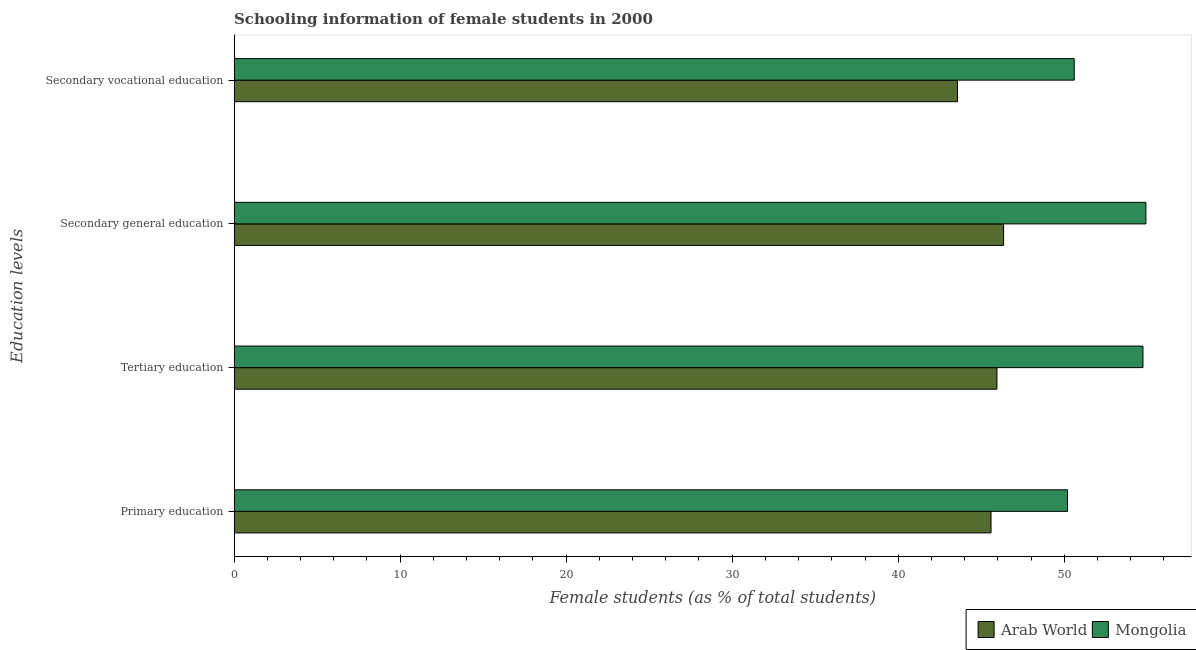How many groups of bars are there?
Keep it short and to the point. 4. Are the number of bars per tick equal to the number of legend labels?
Provide a short and direct response. Yes. Are the number of bars on each tick of the Y-axis equal?
Provide a short and direct response. Yes. How many bars are there on the 1st tick from the bottom?
Ensure brevity in your answer.  2. What is the label of the 2nd group of bars from the top?
Make the answer very short. Secondary general education. What is the percentage of female students in secondary education in Mongolia?
Make the answer very short. 54.92. Across all countries, what is the maximum percentage of female students in secondary education?
Your answer should be compact. 54.92. Across all countries, what is the minimum percentage of female students in primary education?
Keep it short and to the point. 45.59. In which country was the percentage of female students in secondary education maximum?
Offer a terse response. Mongolia. In which country was the percentage of female students in tertiary education minimum?
Your response must be concise. Arab World. What is the total percentage of female students in secondary education in the graph?
Give a very brief answer. 101.27. What is the difference between the percentage of female students in secondary education in Arab World and that in Mongolia?
Your response must be concise. -8.57. What is the difference between the percentage of female students in secondary vocational education in Arab World and the percentage of female students in primary education in Mongolia?
Give a very brief answer. -6.63. What is the average percentage of female students in secondary vocational education per country?
Offer a terse response. 47.09. What is the difference between the percentage of female students in secondary education and percentage of female students in tertiary education in Arab World?
Your response must be concise. 0.4. What is the ratio of the percentage of female students in secondary vocational education in Arab World to that in Mongolia?
Your answer should be very brief. 0.86. What is the difference between the highest and the second highest percentage of female students in secondary vocational education?
Your answer should be compact. 7.03. What is the difference between the highest and the lowest percentage of female students in secondary education?
Make the answer very short. 8.57. Is the sum of the percentage of female students in primary education in Arab World and Mongolia greater than the maximum percentage of female students in tertiary education across all countries?
Offer a very short reply. Yes. What does the 2nd bar from the top in Tertiary education represents?
Your response must be concise. Arab World. What does the 2nd bar from the bottom in Secondary vocational education represents?
Offer a terse response. Mongolia. Is it the case that in every country, the sum of the percentage of female students in primary education and percentage of female students in tertiary education is greater than the percentage of female students in secondary education?
Give a very brief answer. Yes. How many bars are there?
Your response must be concise. 8. What is the difference between two consecutive major ticks on the X-axis?
Offer a very short reply. 10. Are the values on the major ticks of X-axis written in scientific E-notation?
Ensure brevity in your answer.  No. Does the graph contain any zero values?
Your answer should be very brief. No. Does the graph contain grids?
Provide a short and direct response. No. Where does the legend appear in the graph?
Your response must be concise. Bottom right. How are the legend labels stacked?
Provide a succinct answer. Horizontal. What is the title of the graph?
Your answer should be compact. Schooling information of female students in 2000. Does "Congo (Democratic)" appear as one of the legend labels in the graph?
Your answer should be compact. No. What is the label or title of the X-axis?
Provide a succinct answer. Female students (as % of total students). What is the label or title of the Y-axis?
Ensure brevity in your answer.  Education levels. What is the Female students (as % of total students) in Arab World in Primary education?
Make the answer very short. 45.59. What is the Female students (as % of total students) of Mongolia in Primary education?
Your answer should be compact. 50.2. What is the Female students (as % of total students) of Arab World in Tertiary education?
Provide a succinct answer. 45.95. What is the Female students (as % of total students) in Mongolia in Tertiary education?
Your response must be concise. 54.74. What is the Female students (as % of total students) of Arab World in Secondary general education?
Your answer should be compact. 46.35. What is the Female students (as % of total students) of Mongolia in Secondary general education?
Your response must be concise. 54.92. What is the Female students (as % of total students) of Arab World in Secondary vocational education?
Your answer should be compact. 43.57. What is the Female students (as % of total students) of Mongolia in Secondary vocational education?
Keep it short and to the point. 50.6. Across all Education levels, what is the maximum Female students (as % of total students) of Arab World?
Give a very brief answer. 46.35. Across all Education levels, what is the maximum Female students (as % of total students) of Mongolia?
Give a very brief answer. 54.92. Across all Education levels, what is the minimum Female students (as % of total students) of Arab World?
Your answer should be very brief. 43.57. Across all Education levels, what is the minimum Female students (as % of total students) in Mongolia?
Make the answer very short. 50.2. What is the total Female students (as % of total students) of Arab World in the graph?
Provide a succinct answer. 181.46. What is the total Female students (as % of total students) in Mongolia in the graph?
Offer a terse response. 210.46. What is the difference between the Female students (as % of total students) in Arab World in Primary education and that in Tertiary education?
Your answer should be compact. -0.36. What is the difference between the Female students (as % of total students) in Mongolia in Primary education and that in Tertiary education?
Give a very brief answer. -4.54. What is the difference between the Female students (as % of total students) of Arab World in Primary education and that in Secondary general education?
Your response must be concise. -0.76. What is the difference between the Female students (as % of total students) of Mongolia in Primary education and that in Secondary general education?
Keep it short and to the point. -4.72. What is the difference between the Female students (as % of total students) in Arab World in Primary education and that in Secondary vocational education?
Give a very brief answer. 2.02. What is the difference between the Female students (as % of total students) in Mongolia in Primary education and that in Secondary vocational education?
Ensure brevity in your answer.  -0.4. What is the difference between the Female students (as % of total students) of Arab World in Tertiary education and that in Secondary general education?
Offer a very short reply. -0.4. What is the difference between the Female students (as % of total students) in Mongolia in Tertiary education and that in Secondary general education?
Give a very brief answer. -0.18. What is the difference between the Female students (as % of total students) in Arab World in Tertiary education and that in Secondary vocational education?
Ensure brevity in your answer.  2.38. What is the difference between the Female students (as % of total students) in Mongolia in Tertiary education and that in Secondary vocational education?
Your response must be concise. 4.14. What is the difference between the Female students (as % of total students) of Arab World in Secondary general education and that in Secondary vocational education?
Keep it short and to the point. 2.78. What is the difference between the Female students (as % of total students) of Mongolia in Secondary general education and that in Secondary vocational education?
Provide a short and direct response. 4.32. What is the difference between the Female students (as % of total students) of Arab World in Primary education and the Female students (as % of total students) of Mongolia in Tertiary education?
Offer a terse response. -9.15. What is the difference between the Female students (as % of total students) in Arab World in Primary education and the Female students (as % of total students) in Mongolia in Secondary general education?
Offer a very short reply. -9.33. What is the difference between the Female students (as % of total students) in Arab World in Primary education and the Female students (as % of total students) in Mongolia in Secondary vocational education?
Offer a very short reply. -5.01. What is the difference between the Female students (as % of total students) in Arab World in Tertiary education and the Female students (as % of total students) in Mongolia in Secondary general education?
Keep it short and to the point. -8.97. What is the difference between the Female students (as % of total students) in Arab World in Tertiary education and the Female students (as % of total students) in Mongolia in Secondary vocational education?
Give a very brief answer. -4.65. What is the difference between the Female students (as % of total students) of Arab World in Secondary general education and the Female students (as % of total students) of Mongolia in Secondary vocational education?
Make the answer very short. -4.25. What is the average Female students (as % of total students) in Arab World per Education levels?
Make the answer very short. 45.36. What is the average Female students (as % of total students) in Mongolia per Education levels?
Your response must be concise. 52.61. What is the difference between the Female students (as % of total students) in Arab World and Female students (as % of total students) in Mongolia in Primary education?
Your response must be concise. -4.61. What is the difference between the Female students (as % of total students) in Arab World and Female students (as % of total students) in Mongolia in Tertiary education?
Offer a terse response. -8.79. What is the difference between the Female students (as % of total students) of Arab World and Female students (as % of total students) of Mongolia in Secondary general education?
Your response must be concise. -8.57. What is the difference between the Female students (as % of total students) of Arab World and Female students (as % of total students) of Mongolia in Secondary vocational education?
Your answer should be compact. -7.03. What is the ratio of the Female students (as % of total students) of Mongolia in Primary education to that in Tertiary education?
Give a very brief answer. 0.92. What is the ratio of the Female students (as % of total students) in Arab World in Primary education to that in Secondary general education?
Make the answer very short. 0.98. What is the ratio of the Female students (as % of total students) of Mongolia in Primary education to that in Secondary general education?
Offer a very short reply. 0.91. What is the ratio of the Female students (as % of total students) in Arab World in Primary education to that in Secondary vocational education?
Your response must be concise. 1.05. What is the ratio of the Female students (as % of total students) in Mongolia in Primary education to that in Secondary vocational education?
Provide a short and direct response. 0.99. What is the ratio of the Female students (as % of total students) in Arab World in Tertiary education to that in Secondary vocational education?
Make the answer very short. 1.05. What is the ratio of the Female students (as % of total students) of Mongolia in Tertiary education to that in Secondary vocational education?
Keep it short and to the point. 1.08. What is the ratio of the Female students (as % of total students) of Arab World in Secondary general education to that in Secondary vocational education?
Give a very brief answer. 1.06. What is the ratio of the Female students (as % of total students) of Mongolia in Secondary general education to that in Secondary vocational education?
Offer a very short reply. 1.09. What is the difference between the highest and the second highest Female students (as % of total students) in Arab World?
Your answer should be compact. 0.4. What is the difference between the highest and the second highest Female students (as % of total students) of Mongolia?
Ensure brevity in your answer.  0.18. What is the difference between the highest and the lowest Female students (as % of total students) of Arab World?
Offer a terse response. 2.78. What is the difference between the highest and the lowest Female students (as % of total students) of Mongolia?
Provide a short and direct response. 4.72. 